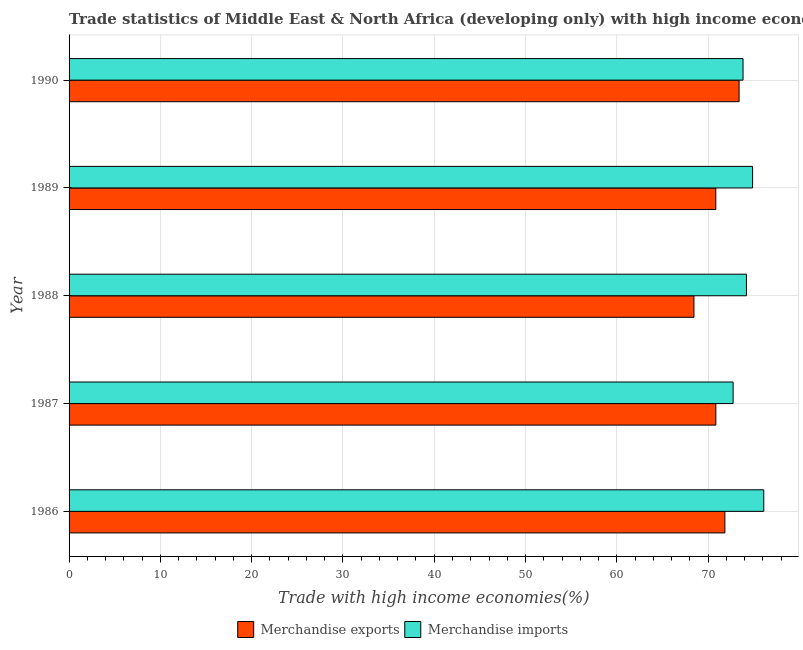How many different coloured bars are there?
Offer a very short reply. 2. How many groups of bars are there?
Make the answer very short. 5. How many bars are there on the 3rd tick from the top?
Your response must be concise. 2. What is the label of the 1st group of bars from the top?
Give a very brief answer. 1990. In how many cases, is the number of bars for a given year not equal to the number of legend labels?
Ensure brevity in your answer.  0. What is the merchandise imports in 1988?
Offer a terse response. 74.2. Across all years, what is the maximum merchandise exports?
Your response must be concise. 73.39. Across all years, what is the minimum merchandise exports?
Keep it short and to the point. 68.45. In which year was the merchandise exports minimum?
Your answer should be very brief. 1988. What is the total merchandise exports in the graph?
Give a very brief answer. 355.36. What is the difference between the merchandise exports in 1987 and that in 1988?
Provide a succinct answer. 2.4. What is the difference between the merchandise imports in 1988 and the merchandise exports in 1986?
Ensure brevity in your answer.  2.36. What is the average merchandise imports per year?
Provide a short and direct response. 74.34. In the year 1988, what is the difference between the merchandise imports and merchandise exports?
Provide a succinct answer. 5.75. What is the ratio of the merchandise imports in 1987 to that in 1989?
Provide a succinct answer. 0.97. What is the difference between the highest and the second highest merchandise imports?
Provide a short and direct response. 1.22. What is the difference between the highest and the lowest merchandise exports?
Your answer should be compact. 4.94. In how many years, is the merchandise exports greater than the average merchandise exports taken over all years?
Your response must be concise. 2. How many years are there in the graph?
Make the answer very short. 5. What is the difference between two consecutive major ticks on the X-axis?
Offer a very short reply. 10. Where does the legend appear in the graph?
Your answer should be very brief. Bottom center. What is the title of the graph?
Provide a short and direct response. Trade statistics of Middle East & North Africa (developing only) with high income economies. What is the label or title of the X-axis?
Provide a short and direct response. Trade with high income economies(%). What is the Trade with high income economies(%) of Merchandise exports in 1986?
Ensure brevity in your answer.  71.83. What is the Trade with high income economies(%) of Merchandise imports in 1986?
Make the answer very short. 76.09. What is the Trade with high income economies(%) of Merchandise exports in 1987?
Your response must be concise. 70.84. What is the Trade with high income economies(%) of Merchandise imports in 1987?
Make the answer very short. 72.74. What is the Trade with high income economies(%) of Merchandise exports in 1988?
Your answer should be very brief. 68.45. What is the Trade with high income economies(%) in Merchandise imports in 1988?
Ensure brevity in your answer.  74.2. What is the Trade with high income economies(%) of Merchandise exports in 1989?
Your answer should be compact. 70.84. What is the Trade with high income economies(%) in Merchandise imports in 1989?
Your answer should be very brief. 74.87. What is the Trade with high income economies(%) in Merchandise exports in 1990?
Your response must be concise. 73.39. What is the Trade with high income economies(%) of Merchandise imports in 1990?
Provide a short and direct response. 73.82. Across all years, what is the maximum Trade with high income economies(%) of Merchandise exports?
Make the answer very short. 73.39. Across all years, what is the maximum Trade with high income economies(%) of Merchandise imports?
Offer a very short reply. 76.09. Across all years, what is the minimum Trade with high income economies(%) of Merchandise exports?
Your answer should be compact. 68.45. Across all years, what is the minimum Trade with high income economies(%) in Merchandise imports?
Provide a short and direct response. 72.74. What is the total Trade with high income economies(%) of Merchandise exports in the graph?
Offer a very short reply. 355.36. What is the total Trade with high income economies(%) of Merchandise imports in the graph?
Your answer should be compact. 371.72. What is the difference between the Trade with high income economies(%) in Merchandise exports in 1986 and that in 1987?
Your answer should be very brief. 0.99. What is the difference between the Trade with high income economies(%) of Merchandise imports in 1986 and that in 1987?
Your response must be concise. 3.36. What is the difference between the Trade with high income economies(%) of Merchandise exports in 1986 and that in 1988?
Give a very brief answer. 3.39. What is the difference between the Trade with high income economies(%) in Merchandise imports in 1986 and that in 1988?
Your response must be concise. 1.9. What is the difference between the Trade with high income economies(%) in Merchandise exports in 1986 and that in 1989?
Give a very brief answer. 0.99. What is the difference between the Trade with high income economies(%) in Merchandise imports in 1986 and that in 1989?
Your response must be concise. 1.22. What is the difference between the Trade with high income economies(%) in Merchandise exports in 1986 and that in 1990?
Your answer should be compact. -1.56. What is the difference between the Trade with high income economies(%) in Merchandise imports in 1986 and that in 1990?
Make the answer very short. 2.27. What is the difference between the Trade with high income economies(%) of Merchandise exports in 1987 and that in 1988?
Your response must be concise. 2.4. What is the difference between the Trade with high income economies(%) of Merchandise imports in 1987 and that in 1988?
Offer a terse response. -1.46. What is the difference between the Trade with high income economies(%) in Merchandise exports in 1987 and that in 1989?
Give a very brief answer. 0.01. What is the difference between the Trade with high income economies(%) in Merchandise imports in 1987 and that in 1989?
Offer a very short reply. -2.13. What is the difference between the Trade with high income economies(%) of Merchandise exports in 1987 and that in 1990?
Offer a terse response. -2.55. What is the difference between the Trade with high income economies(%) of Merchandise imports in 1987 and that in 1990?
Your response must be concise. -1.09. What is the difference between the Trade with high income economies(%) of Merchandise exports in 1988 and that in 1989?
Give a very brief answer. -2.39. What is the difference between the Trade with high income economies(%) of Merchandise imports in 1988 and that in 1989?
Your response must be concise. -0.67. What is the difference between the Trade with high income economies(%) in Merchandise exports in 1988 and that in 1990?
Your answer should be compact. -4.94. What is the difference between the Trade with high income economies(%) in Merchandise imports in 1988 and that in 1990?
Provide a succinct answer. 0.37. What is the difference between the Trade with high income economies(%) of Merchandise exports in 1989 and that in 1990?
Keep it short and to the point. -2.55. What is the difference between the Trade with high income economies(%) of Merchandise imports in 1989 and that in 1990?
Your response must be concise. 1.04. What is the difference between the Trade with high income economies(%) in Merchandise exports in 1986 and the Trade with high income economies(%) in Merchandise imports in 1987?
Ensure brevity in your answer.  -0.9. What is the difference between the Trade with high income economies(%) of Merchandise exports in 1986 and the Trade with high income economies(%) of Merchandise imports in 1988?
Your response must be concise. -2.36. What is the difference between the Trade with high income economies(%) in Merchandise exports in 1986 and the Trade with high income economies(%) in Merchandise imports in 1989?
Make the answer very short. -3.04. What is the difference between the Trade with high income economies(%) in Merchandise exports in 1986 and the Trade with high income economies(%) in Merchandise imports in 1990?
Offer a terse response. -1.99. What is the difference between the Trade with high income economies(%) in Merchandise exports in 1987 and the Trade with high income economies(%) in Merchandise imports in 1988?
Provide a succinct answer. -3.35. What is the difference between the Trade with high income economies(%) of Merchandise exports in 1987 and the Trade with high income economies(%) of Merchandise imports in 1989?
Keep it short and to the point. -4.02. What is the difference between the Trade with high income economies(%) of Merchandise exports in 1987 and the Trade with high income economies(%) of Merchandise imports in 1990?
Provide a succinct answer. -2.98. What is the difference between the Trade with high income economies(%) in Merchandise exports in 1988 and the Trade with high income economies(%) in Merchandise imports in 1989?
Ensure brevity in your answer.  -6.42. What is the difference between the Trade with high income economies(%) of Merchandise exports in 1988 and the Trade with high income economies(%) of Merchandise imports in 1990?
Make the answer very short. -5.38. What is the difference between the Trade with high income economies(%) of Merchandise exports in 1989 and the Trade with high income economies(%) of Merchandise imports in 1990?
Offer a very short reply. -2.99. What is the average Trade with high income economies(%) in Merchandise exports per year?
Offer a very short reply. 71.07. What is the average Trade with high income economies(%) in Merchandise imports per year?
Your response must be concise. 74.34. In the year 1986, what is the difference between the Trade with high income economies(%) in Merchandise exports and Trade with high income economies(%) in Merchandise imports?
Make the answer very short. -4.26. In the year 1987, what is the difference between the Trade with high income economies(%) in Merchandise exports and Trade with high income economies(%) in Merchandise imports?
Offer a very short reply. -1.89. In the year 1988, what is the difference between the Trade with high income economies(%) in Merchandise exports and Trade with high income economies(%) in Merchandise imports?
Make the answer very short. -5.75. In the year 1989, what is the difference between the Trade with high income economies(%) in Merchandise exports and Trade with high income economies(%) in Merchandise imports?
Keep it short and to the point. -4.03. In the year 1990, what is the difference between the Trade with high income economies(%) in Merchandise exports and Trade with high income economies(%) in Merchandise imports?
Keep it short and to the point. -0.43. What is the ratio of the Trade with high income economies(%) in Merchandise imports in 1986 to that in 1987?
Give a very brief answer. 1.05. What is the ratio of the Trade with high income economies(%) of Merchandise exports in 1986 to that in 1988?
Keep it short and to the point. 1.05. What is the ratio of the Trade with high income economies(%) of Merchandise imports in 1986 to that in 1988?
Offer a terse response. 1.03. What is the ratio of the Trade with high income economies(%) in Merchandise exports in 1986 to that in 1989?
Offer a very short reply. 1.01. What is the ratio of the Trade with high income economies(%) of Merchandise imports in 1986 to that in 1989?
Offer a terse response. 1.02. What is the ratio of the Trade with high income economies(%) in Merchandise exports in 1986 to that in 1990?
Provide a succinct answer. 0.98. What is the ratio of the Trade with high income economies(%) of Merchandise imports in 1986 to that in 1990?
Offer a very short reply. 1.03. What is the ratio of the Trade with high income economies(%) of Merchandise exports in 1987 to that in 1988?
Ensure brevity in your answer.  1.03. What is the ratio of the Trade with high income economies(%) of Merchandise imports in 1987 to that in 1988?
Your answer should be very brief. 0.98. What is the ratio of the Trade with high income economies(%) of Merchandise imports in 1987 to that in 1989?
Ensure brevity in your answer.  0.97. What is the ratio of the Trade with high income economies(%) in Merchandise exports in 1987 to that in 1990?
Provide a short and direct response. 0.97. What is the ratio of the Trade with high income economies(%) of Merchandise imports in 1987 to that in 1990?
Ensure brevity in your answer.  0.99. What is the ratio of the Trade with high income economies(%) of Merchandise exports in 1988 to that in 1989?
Give a very brief answer. 0.97. What is the ratio of the Trade with high income economies(%) in Merchandise imports in 1988 to that in 1989?
Make the answer very short. 0.99. What is the ratio of the Trade with high income economies(%) of Merchandise exports in 1988 to that in 1990?
Ensure brevity in your answer.  0.93. What is the ratio of the Trade with high income economies(%) of Merchandise exports in 1989 to that in 1990?
Your response must be concise. 0.97. What is the ratio of the Trade with high income economies(%) of Merchandise imports in 1989 to that in 1990?
Provide a succinct answer. 1.01. What is the difference between the highest and the second highest Trade with high income economies(%) in Merchandise exports?
Your response must be concise. 1.56. What is the difference between the highest and the second highest Trade with high income economies(%) in Merchandise imports?
Ensure brevity in your answer.  1.22. What is the difference between the highest and the lowest Trade with high income economies(%) of Merchandise exports?
Your answer should be compact. 4.94. What is the difference between the highest and the lowest Trade with high income economies(%) of Merchandise imports?
Keep it short and to the point. 3.36. 